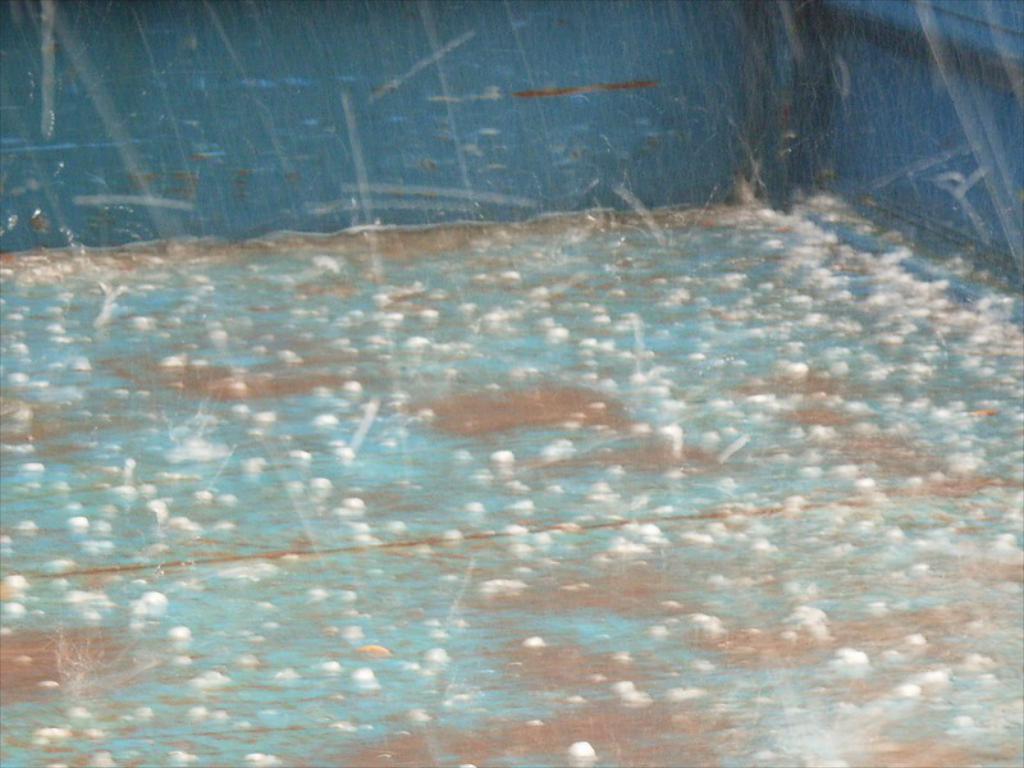How would you summarize this image in a sentence or two? In the image there are raindrops falling on a surface and there are many ice pieces on the floor, in the background there is a blue surface. 